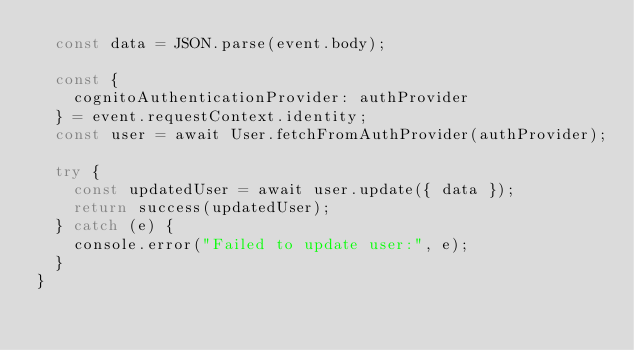Convert code to text. <code><loc_0><loc_0><loc_500><loc_500><_JavaScript_>  const data = JSON.parse(event.body);

  const {
    cognitoAuthenticationProvider: authProvider
  } = event.requestContext.identity;
  const user = await User.fetchFromAuthProvider(authProvider);

  try {
    const updatedUser = await user.update({ data });
    return success(updatedUser);
  } catch (e) {
    console.error("Failed to update user:", e);
  }
}
</code> 